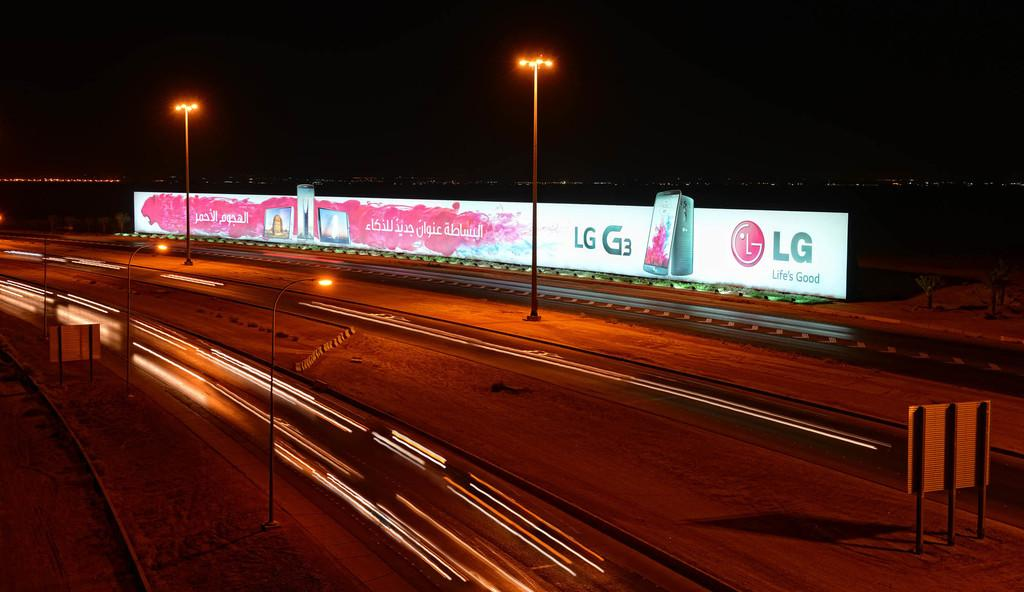What type of structures can be seen in the image? There are street lights and boards visible in the image. What type of infrastructure is present in the image? There are roads in the image. What type of advertising is present in the image? There is a hoarding in the image. What is the color of the background in the image? The background of the image is dark. Can you tell me how many eggs are being carried by the yak in the image? There is no yak or eggs present in the image. What type of drink is being served in the hoarding in the image? The image does not show any drinks being served; it only features a hoarding with advertising. 